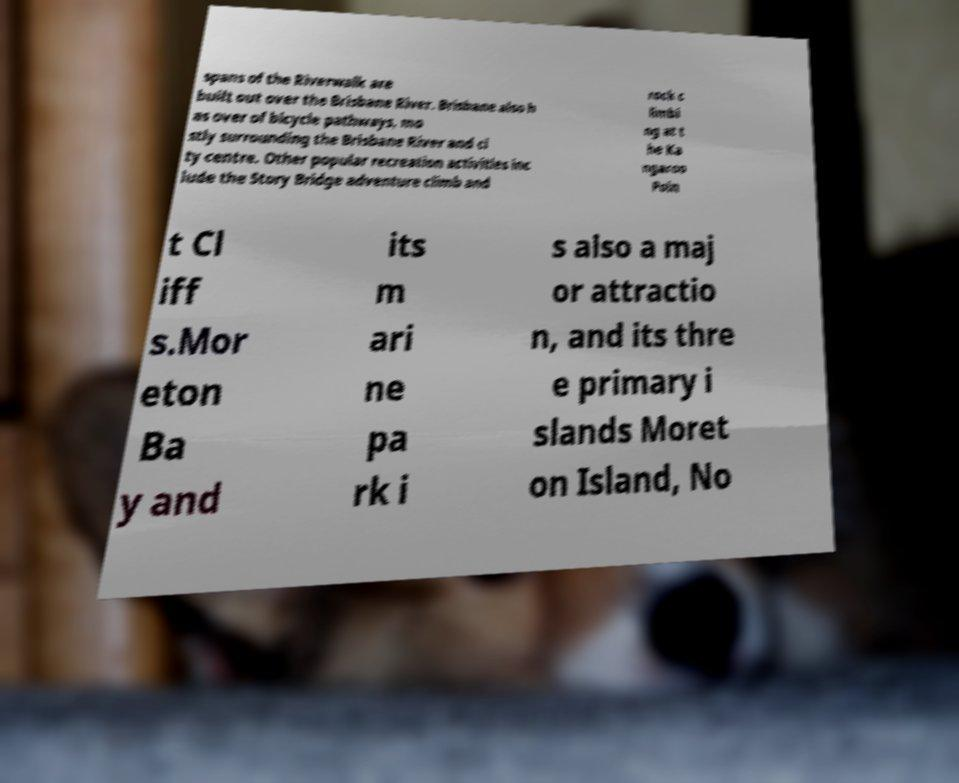What messages or text are displayed in this image? I need them in a readable, typed format. spans of the Riverwalk are built out over the Brisbane River. Brisbane also h as over of bicycle pathways, mo stly surrounding the Brisbane River and ci ty centre. Other popular recreation activities inc lude the Story Bridge adventure climb and rock c limbi ng at t he Ka ngaroo Poin t Cl iff s.Mor eton Ba y and its m ari ne pa rk i s also a maj or attractio n, and its thre e primary i slands Moret on Island, No 